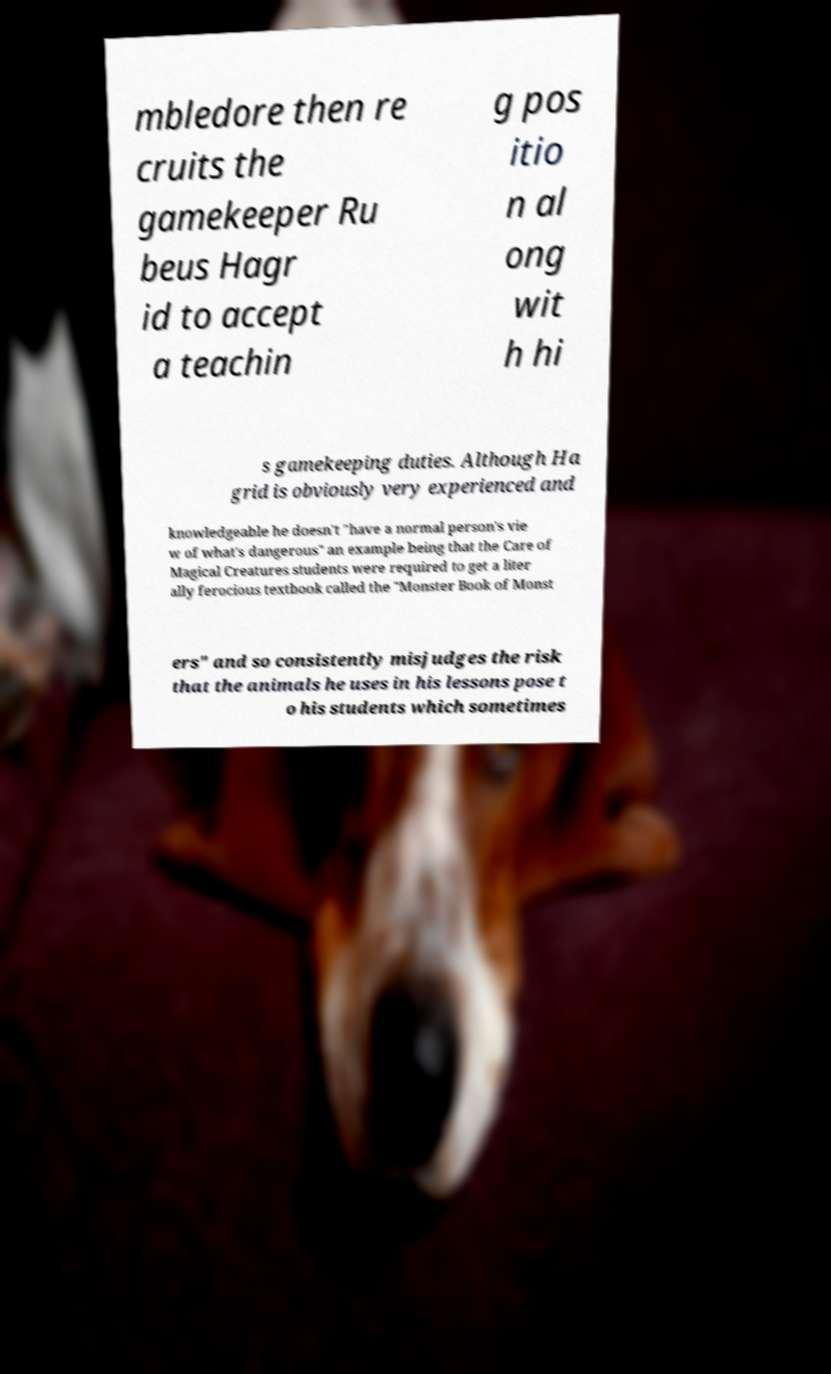For documentation purposes, I need the text within this image transcribed. Could you provide that? mbledore then re cruits the gamekeeper Ru beus Hagr id to accept a teachin g pos itio n al ong wit h hi s gamekeeping duties. Although Ha grid is obviously very experienced and knowledgeable he doesn't "have a normal person's vie w of what's dangerous" an example being that the Care of Magical Creatures students were required to get a liter ally ferocious textbook called the "Monster Book of Monst ers" and so consistently misjudges the risk that the animals he uses in his lessons pose t o his students which sometimes 